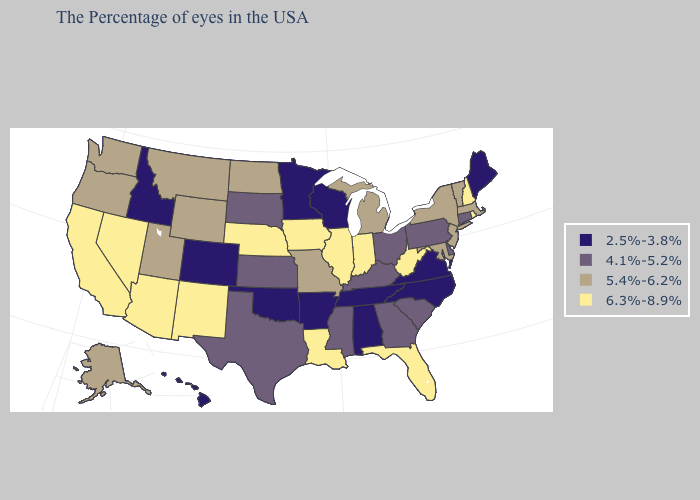What is the highest value in the MidWest ?
Answer briefly. 6.3%-8.9%. Does the map have missing data?
Be succinct. No. Among the states that border North Dakota , which have the lowest value?
Give a very brief answer. Minnesota. Does Wyoming have a lower value than California?
Quick response, please. Yes. Name the states that have a value in the range 4.1%-5.2%?
Be succinct. Connecticut, Delaware, Pennsylvania, South Carolina, Ohio, Georgia, Kentucky, Mississippi, Kansas, Texas, South Dakota. Among the states that border North Dakota , which have the lowest value?
Keep it brief. Minnesota. What is the value of Minnesota?
Give a very brief answer. 2.5%-3.8%. Name the states that have a value in the range 5.4%-6.2%?
Be succinct. Massachusetts, Vermont, New York, New Jersey, Maryland, Michigan, Missouri, North Dakota, Wyoming, Utah, Montana, Washington, Oregon, Alaska. Does New Hampshire have the highest value in the Northeast?
Give a very brief answer. Yes. What is the value of Rhode Island?
Answer briefly. 6.3%-8.9%. Name the states that have a value in the range 4.1%-5.2%?
Short answer required. Connecticut, Delaware, Pennsylvania, South Carolina, Ohio, Georgia, Kentucky, Mississippi, Kansas, Texas, South Dakota. What is the value of Colorado?
Be succinct. 2.5%-3.8%. Among the states that border Ohio , which have the highest value?
Give a very brief answer. West Virginia, Indiana. Does West Virginia have the highest value in the USA?
Write a very short answer. Yes. 